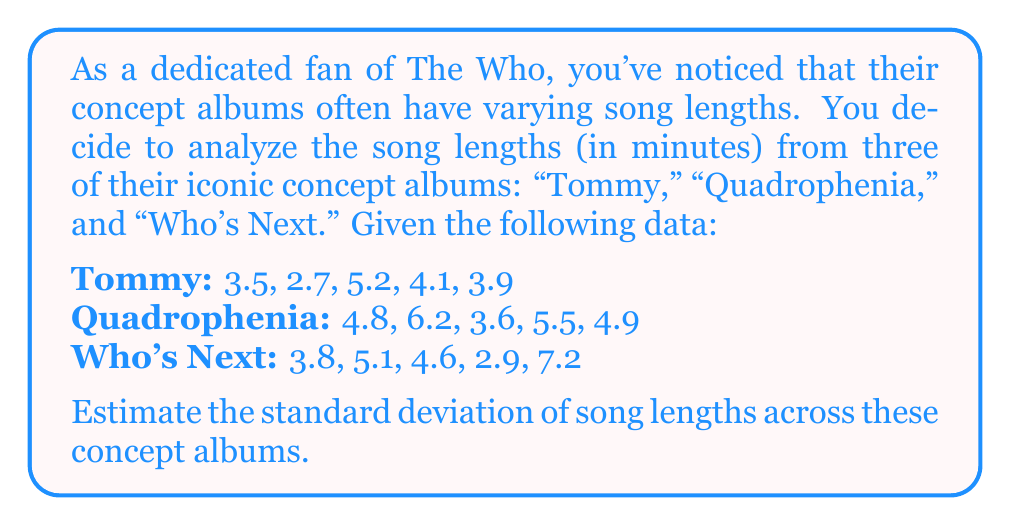Can you solve this math problem? To estimate the standard deviation of song lengths, we'll follow these steps:

1. Calculate the mean (average) of all song lengths:
   $$\bar{x} = \frac{\sum_{i=1}^{n} x_i}{n}$$
   where $x_i$ are the individual song lengths and $n$ is the total number of songs.

   $\bar{x} = \frac{3.5 + 2.7 + 5.2 + 4.1 + 3.9 + 4.8 + 6.2 + 3.6 + 5.5 + 4.9 + 3.8 + 5.1 + 4.6 + 2.9 + 7.2}{15} = 4.53$ minutes

2. Calculate the squared differences from the mean:
   $$(x_i - \bar{x})^2$$

3. Sum the squared differences:
   $$\sum_{i=1}^{n} (x_i - \bar{x})^2$$

4. Calculate the variance by dividing the sum of squared differences by $(n-1)$:
   $$s^2 = \frac{\sum_{i=1}^{n} (x_i - \bar{x})^2}{n-1}$$

5. Take the square root of the variance to get the standard deviation:
   $$s = \sqrt{\frac{\sum_{i=1}^{n} (x_i - \bar{x})^2}{n-1}}$$

Calculating the squared differences and summing them:
$$(3.5 - 4.53)^2 + (2.7 - 4.53)^2 + ... + (7.2 - 4.53)^2 = 30.9956$$

Now, we can calculate the standard deviation:

$$s = \sqrt{\frac{30.9956}{15-1}} = \sqrt{2.2140} \approx 1.49$$
Answer: $1.49$ minutes 